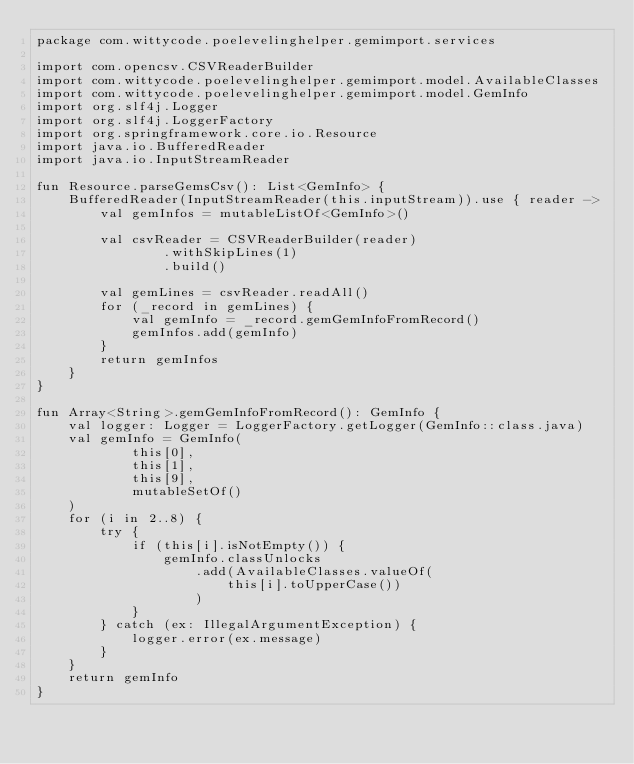<code> <loc_0><loc_0><loc_500><loc_500><_Kotlin_>package com.wittycode.poelevelinghelper.gemimport.services

import com.opencsv.CSVReaderBuilder
import com.wittycode.poelevelinghelper.gemimport.model.AvailableClasses
import com.wittycode.poelevelinghelper.gemimport.model.GemInfo
import org.slf4j.Logger
import org.slf4j.LoggerFactory
import org.springframework.core.io.Resource
import java.io.BufferedReader
import java.io.InputStreamReader

fun Resource.parseGemsCsv(): List<GemInfo> {
    BufferedReader(InputStreamReader(this.inputStream)).use { reader ->
        val gemInfos = mutableListOf<GemInfo>()

        val csvReader = CSVReaderBuilder(reader)
                .withSkipLines(1)
                .build()

        val gemLines = csvReader.readAll()
        for (_record in gemLines) {
            val gemInfo = _record.gemGemInfoFromRecord()
            gemInfos.add(gemInfo)
        }
        return gemInfos
    }
}

fun Array<String>.gemGemInfoFromRecord(): GemInfo {
    val logger: Logger = LoggerFactory.getLogger(GemInfo::class.java)
    val gemInfo = GemInfo(
            this[0],
            this[1],
            this[9],
            mutableSetOf()
    )
    for (i in 2..8) {
        try {
            if (this[i].isNotEmpty()) {
                gemInfo.classUnlocks
                    .add(AvailableClasses.valueOf(
                        this[i].toUpperCase())
                    )
            }
        } catch (ex: IllegalArgumentException) {
            logger.error(ex.message)
        }
    }
    return gemInfo
}</code> 